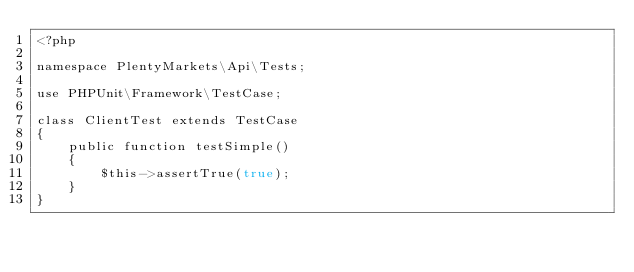Convert code to text. <code><loc_0><loc_0><loc_500><loc_500><_PHP_><?php

namespace PlentyMarkets\Api\Tests;

use PHPUnit\Framework\TestCase;

class ClientTest extends TestCase
{
    public function testSimple()
    {
        $this->assertTrue(true);
    }
}
</code> 